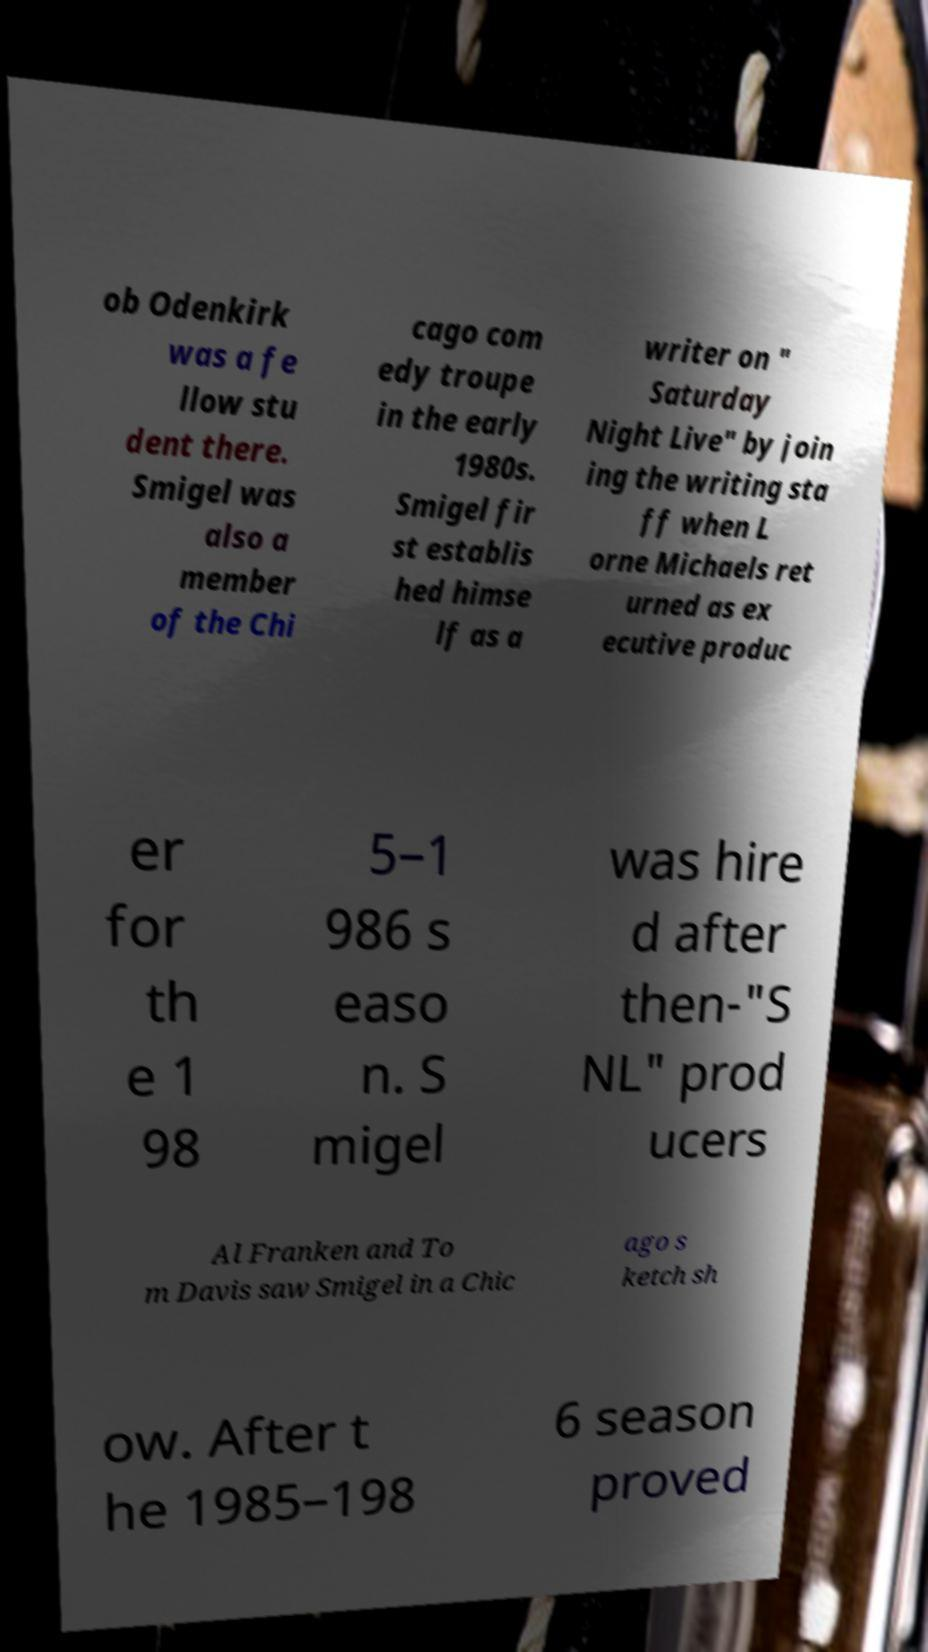Could you extract and type out the text from this image? ob Odenkirk was a fe llow stu dent there. Smigel was also a member of the Chi cago com edy troupe in the early 1980s. Smigel fir st establis hed himse lf as a writer on " Saturday Night Live" by join ing the writing sta ff when L orne Michaels ret urned as ex ecutive produc er for th e 1 98 5–1 986 s easo n. S migel was hire d after then-"S NL" prod ucers Al Franken and To m Davis saw Smigel in a Chic ago s ketch sh ow. After t he 1985–198 6 season proved 